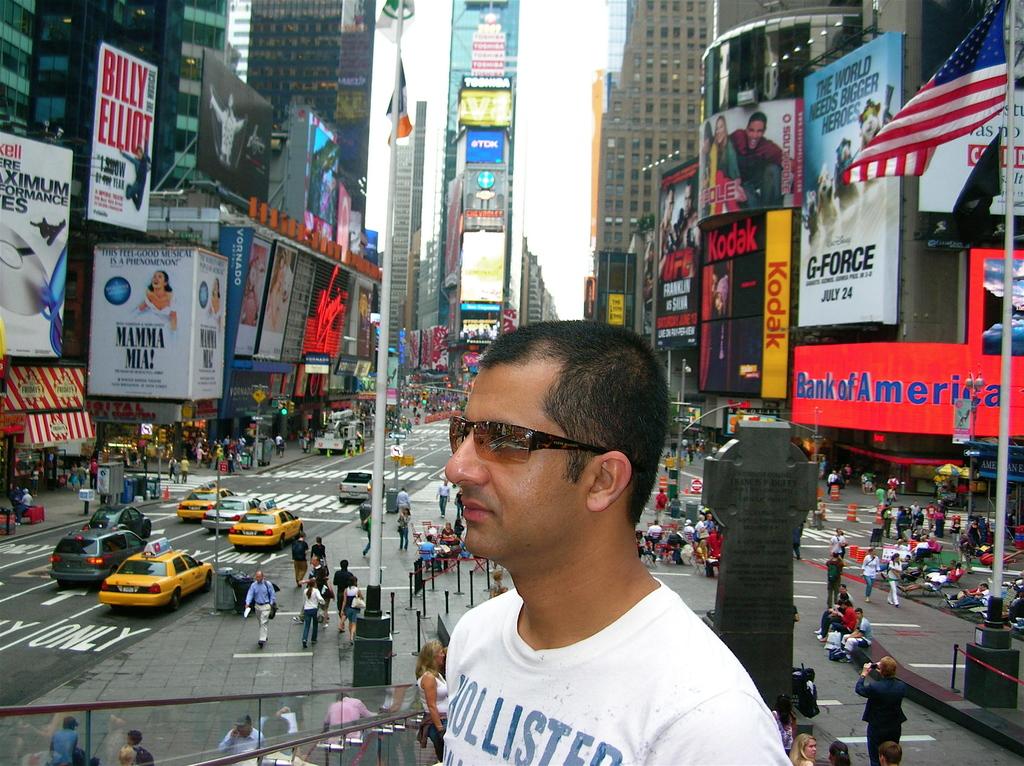What does his shirt say?
Ensure brevity in your answer.  Hollister. What bank is on the right?
Your response must be concise. Bank of america. 